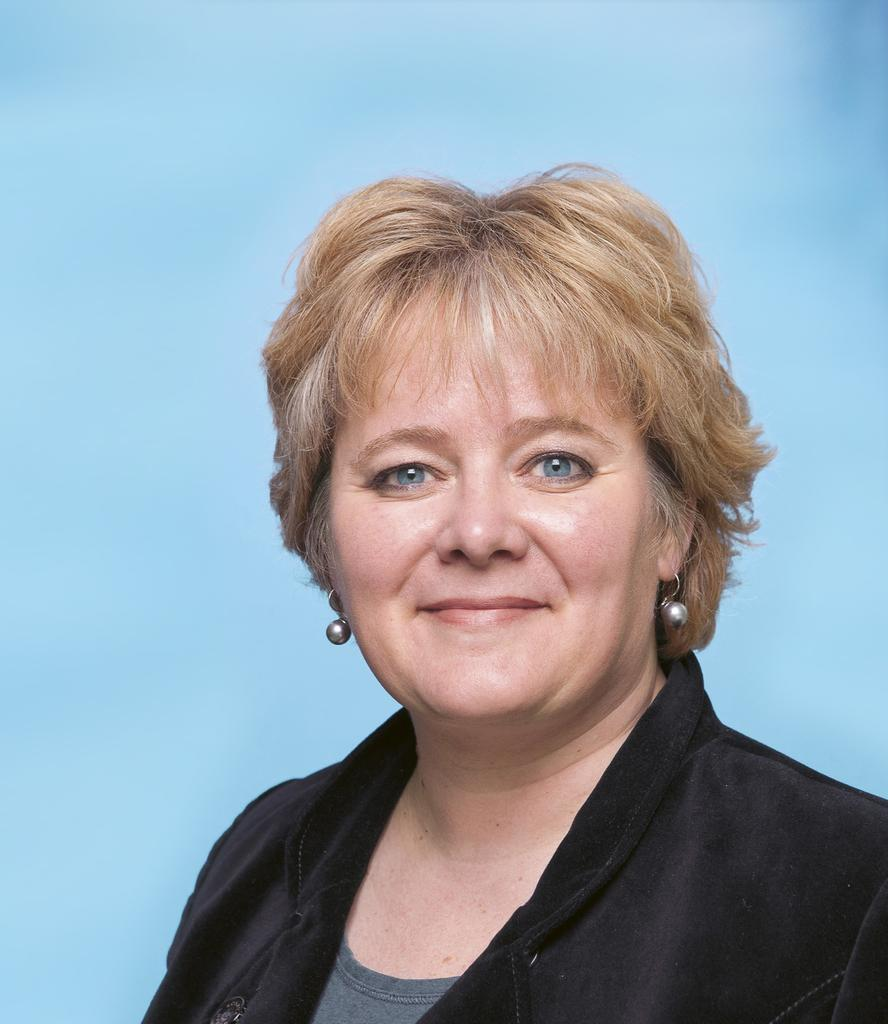Who is the main subject in the image? There is a woman in the image. What is the woman wearing? The woman is wearing a white dress. What expression does the woman have? The woman is smiling. What might be the reason for the woman's pose in the image? The woman might be posing for the photo. What color are the woman's eyes? The woman has blue eyes. What is the color of the background in the image? The background of the image is blue in color. What type of pancake is the woman holding in the image? There is no pancake present in the image; the woman is not holding anything. 